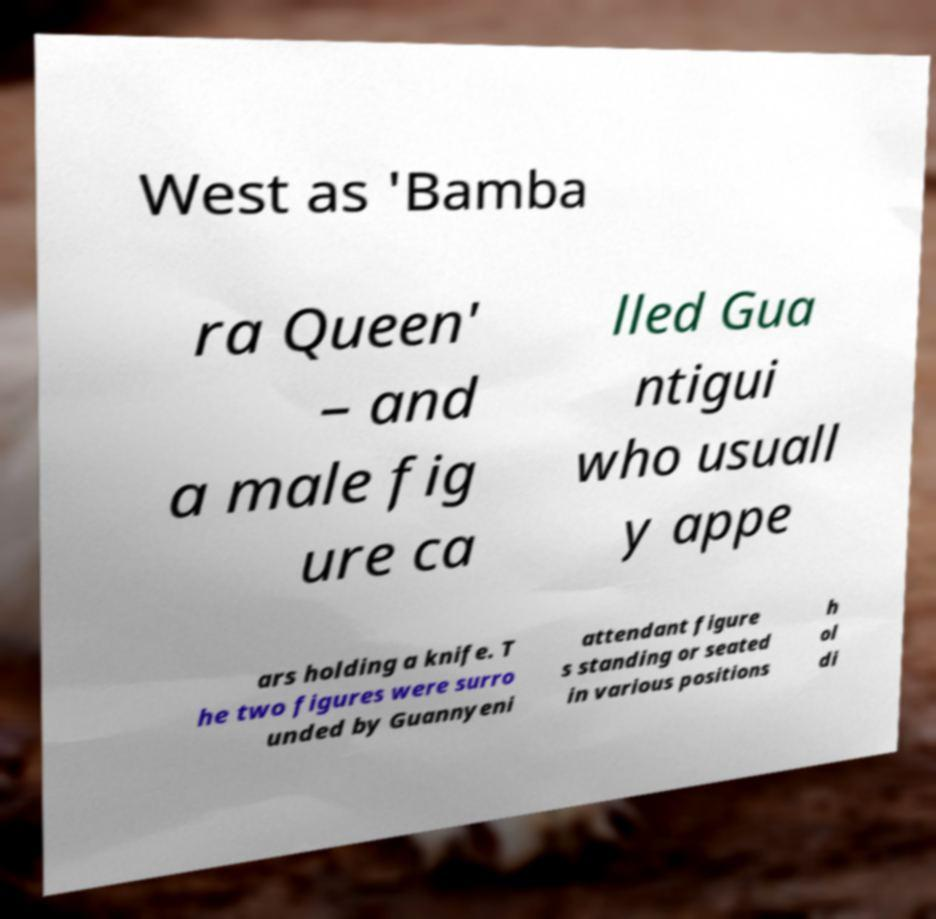Can you read and provide the text displayed in the image?This photo seems to have some interesting text. Can you extract and type it out for me? West as 'Bamba ra Queen' – and a male fig ure ca lled Gua ntigui who usuall y appe ars holding a knife. T he two figures were surro unded by Guannyeni attendant figure s standing or seated in various positions h ol di 